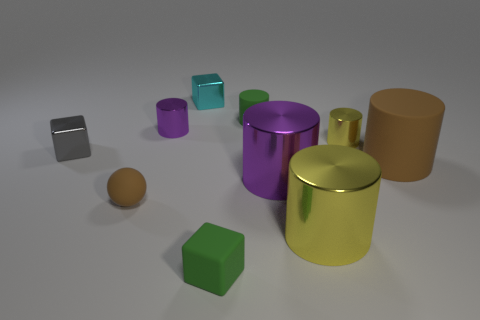Subtract all purple cylinders. How many cylinders are left? 4 Subtract all green cubes. How many cubes are left? 2 Subtract 5 cylinders. How many cylinders are left? 1 Subtract all brown blocks. Subtract all gray cylinders. How many blocks are left? 3 Subtract all green cubes. How many green cylinders are left? 1 Subtract all tiny green cylinders. Subtract all gray objects. How many objects are left? 8 Add 9 cyan metal objects. How many cyan metal objects are left? 10 Add 2 large rubber things. How many large rubber things exist? 3 Subtract 1 brown balls. How many objects are left? 9 Subtract all cylinders. How many objects are left? 4 